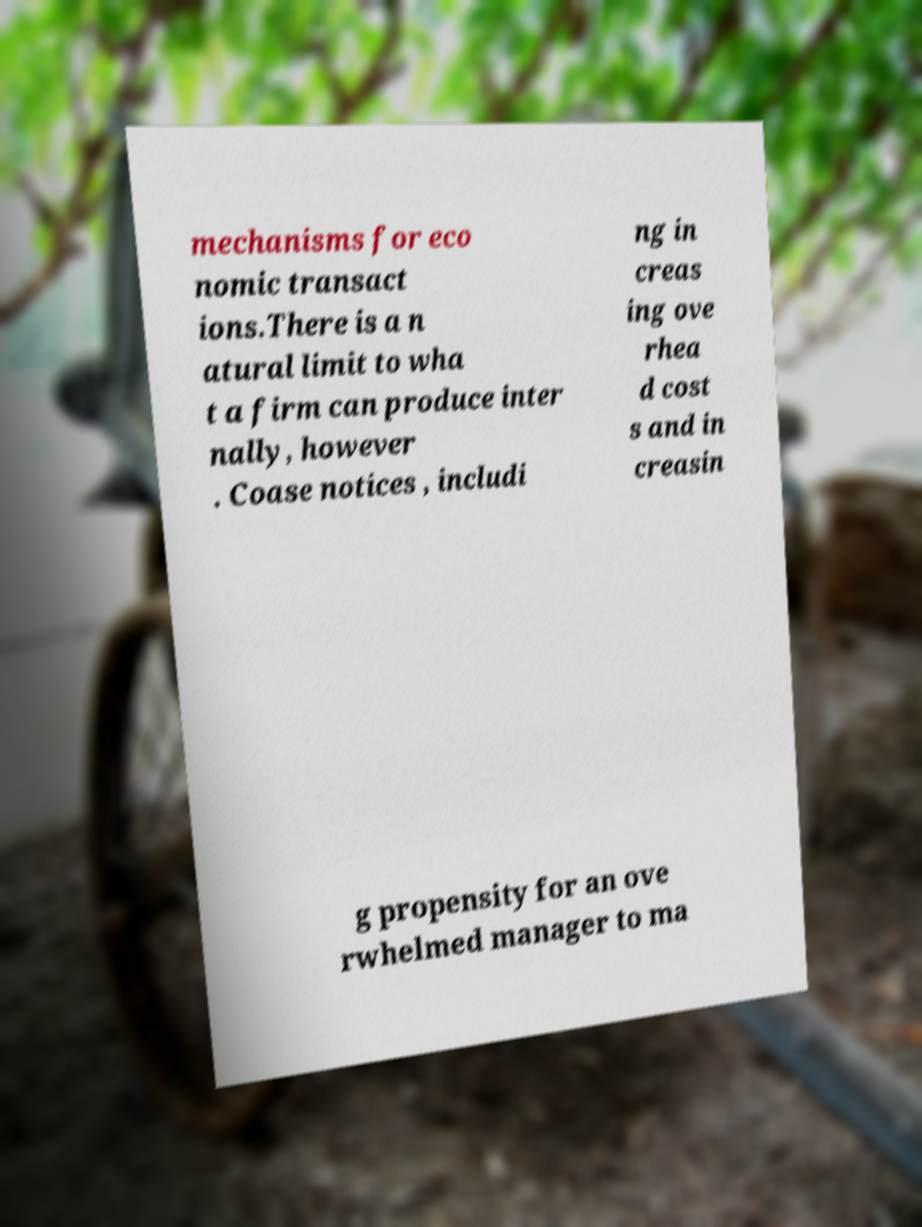Can you read and provide the text displayed in the image?This photo seems to have some interesting text. Can you extract and type it out for me? mechanisms for eco nomic transact ions.There is a n atural limit to wha t a firm can produce inter nally, however . Coase notices , includi ng in creas ing ove rhea d cost s and in creasin g propensity for an ove rwhelmed manager to ma 